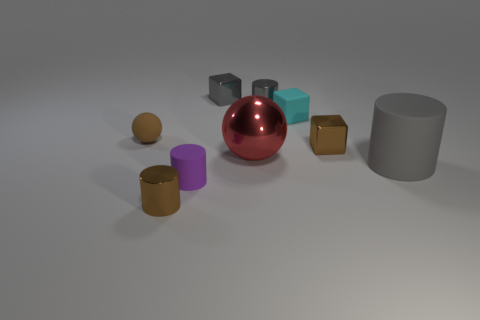How many objects in total are displayed in the image, and can you identify their shapes? There are eight objects in total. Starting from the left, there's a brown cylinder, a pink cylinder, a red sphere, a blue cube, a grey cube, a brown cube, a gold sphere, and a grey cylinder. What’s the largest object in the scene? The red sphere appears to be the largest object in the scene in terms of volume. 